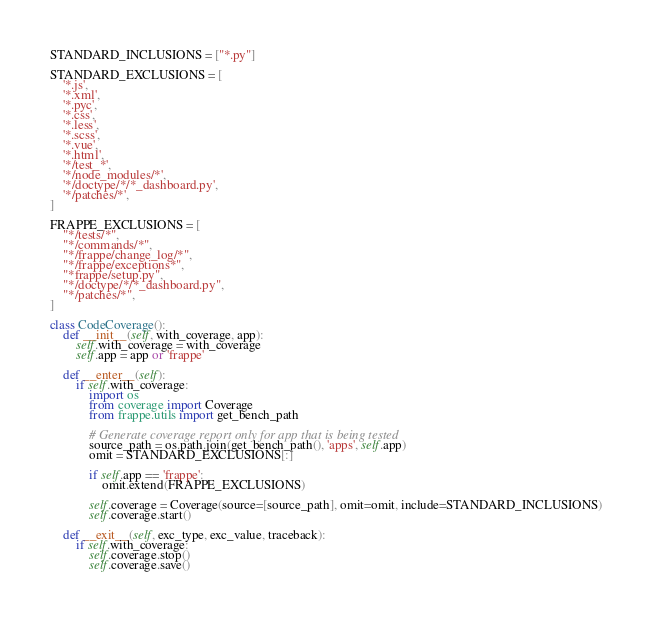Convert code to text. <code><loc_0><loc_0><loc_500><loc_500><_Python_>
STANDARD_INCLUSIONS = ["*.py"]

STANDARD_EXCLUSIONS = [
	'*.js',
	'*.xml',
	'*.pyc',
	'*.css',
	'*.less',
	'*.scss',
	'*.vue',
	'*.html',
	'*/test_*',
	'*/node_modules/*',
	'*/doctype/*/*_dashboard.py',
	'*/patches/*',
]

FRAPPE_EXCLUSIONS = [
	"*/tests/*",
	"*/commands/*",
	"*/frappe/change_log/*",
	"*/frappe/exceptions*",
	"*frappe/setup.py",
	"*/doctype/*/*_dashboard.py",
	"*/patches/*",
]

class CodeCoverage():
	def __init__(self, with_coverage, app):
		self.with_coverage = with_coverage
		self.app = app or 'frappe'

	def __enter__(self):
		if self.with_coverage:
			import os
			from coverage import Coverage
			from frappe.utils import get_bench_path

			# Generate coverage report only for app that is being tested
			source_path = os.path.join(get_bench_path(), 'apps', self.app)
			omit = STANDARD_EXCLUSIONS[:]

			if self.app == 'frappe':
				omit.extend(FRAPPE_EXCLUSIONS)

			self.coverage = Coverage(source=[source_path], omit=omit, include=STANDARD_INCLUSIONS)
			self.coverage.start()

	def __exit__(self, exc_type, exc_value, traceback):
		if self.with_coverage:
			self.coverage.stop()
			self.coverage.save()</code> 